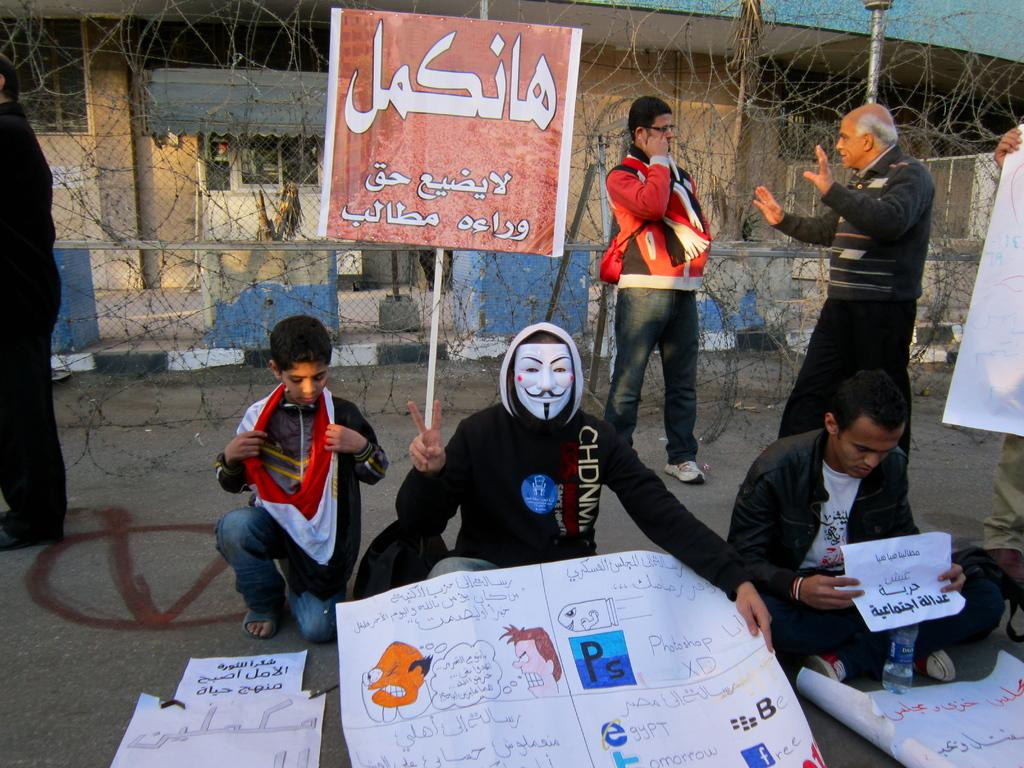How many people are in the image? There are persons in the image, but the exact number is not specified. What are the persons holding in the image? The persons are holding posters in the image. Can you describe the attire of one of the persons? At least one person is wearing a mask in the image. What is the background of the image? There is a building in the background of the image. What object can be seen in the foreground of the image? There is a board in the image. What type of bead is being used to create harmony in the image? There is no mention of beads or harmony in the image, so this question cannot be answered. 